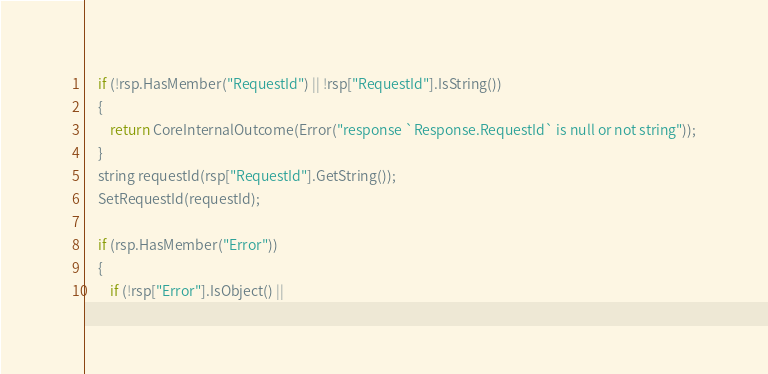Convert code to text. <code><loc_0><loc_0><loc_500><loc_500><_C++_>    if (!rsp.HasMember("RequestId") || !rsp["RequestId"].IsString())
    {
        return CoreInternalOutcome(Error("response `Response.RequestId` is null or not string"));
    }
    string requestId(rsp["RequestId"].GetString());
    SetRequestId(requestId);

    if (rsp.HasMember("Error"))
    {
        if (!rsp["Error"].IsObject() ||</code> 